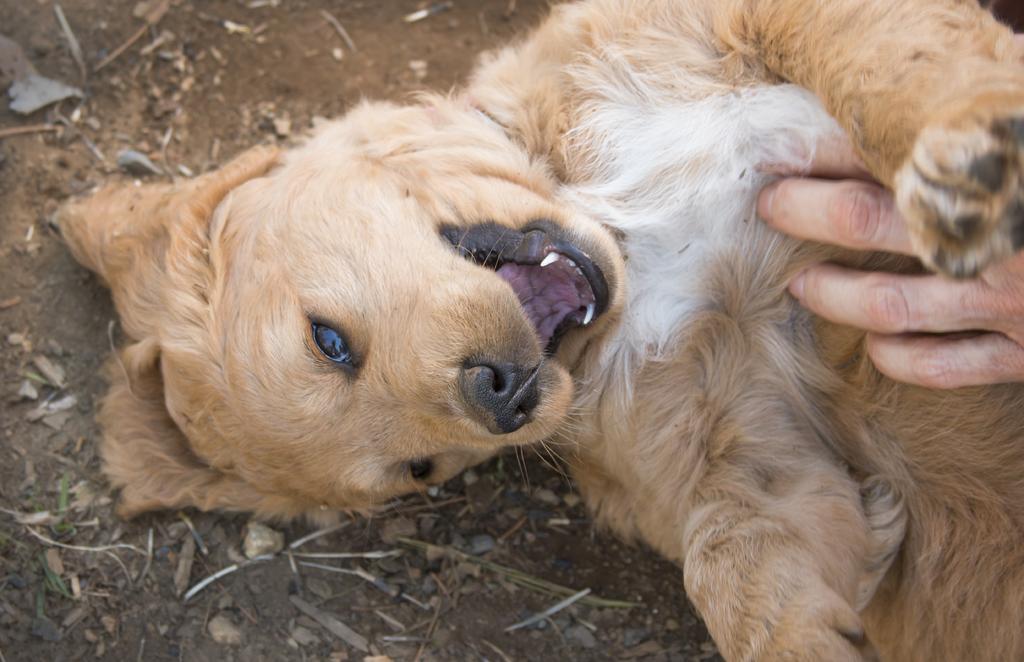How would you summarize this image in a sentence or two? In the image we can see a dog, light brown and white in color. There is a human hand and there is sand. 